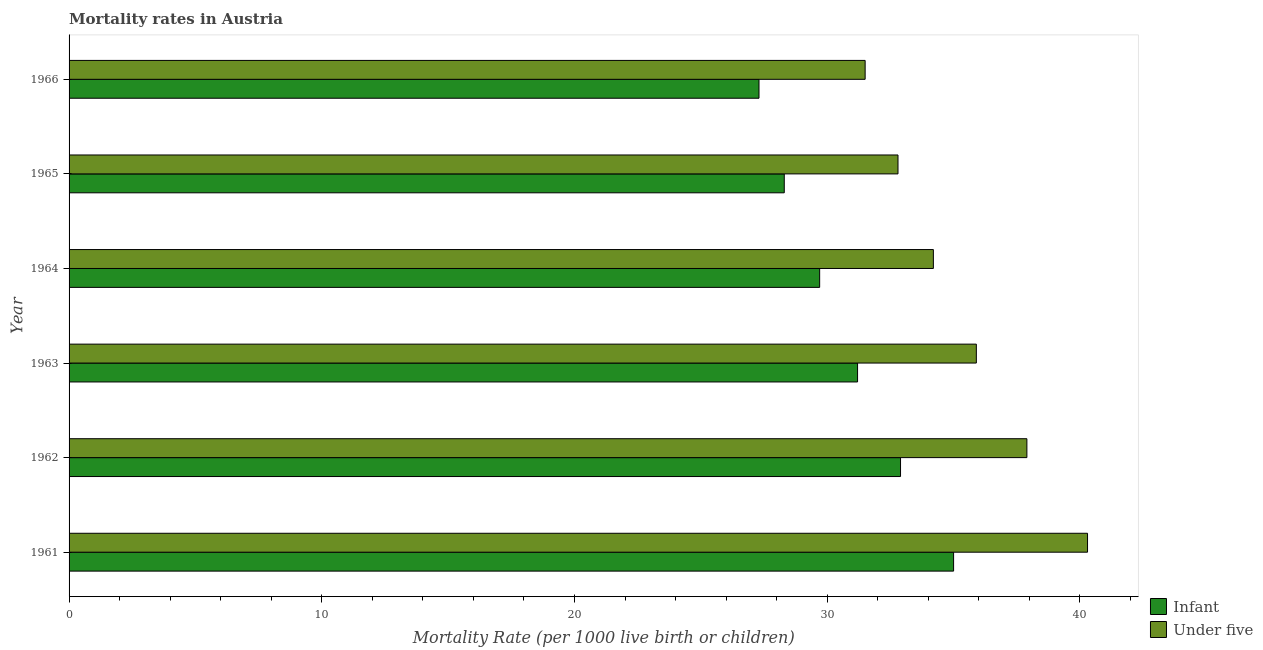How many different coloured bars are there?
Give a very brief answer. 2. What is the label of the 1st group of bars from the top?
Keep it short and to the point. 1966. In how many cases, is the number of bars for a given year not equal to the number of legend labels?
Provide a short and direct response. 0. What is the infant mortality rate in 1965?
Offer a terse response. 28.3. Across all years, what is the maximum under-5 mortality rate?
Your answer should be compact. 40.3. Across all years, what is the minimum under-5 mortality rate?
Your answer should be compact. 31.5. In which year was the under-5 mortality rate maximum?
Your response must be concise. 1961. In which year was the infant mortality rate minimum?
Your response must be concise. 1966. What is the total under-5 mortality rate in the graph?
Provide a succinct answer. 212.6. What is the difference between the under-5 mortality rate in 1963 and that in 1966?
Offer a terse response. 4.4. What is the difference between the infant mortality rate in 1962 and the under-5 mortality rate in 1966?
Offer a very short reply. 1.4. What is the average infant mortality rate per year?
Make the answer very short. 30.73. What is the ratio of the under-5 mortality rate in 1964 to that in 1965?
Your response must be concise. 1.04. Is the difference between the infant mortality rate in 1961 and 1963 greater than the difference between the under-5 mortality rate in 1961 and 1963?
Your answer should be very brief. No. What does the 2nd bar from the top in 1964 represents?
Keep it short and to the point. Infant. What does the 2nd bar from the bottom in 1962 represents?
Provide a short and direct response. Under five. How many bars are there?
Keep it short and to the point. 12. Are all the bars in the graph horizontal?
Ensure brevity in your answer.  Yes. How many years are there in the graph?
Keep it short and to the point. 6. What is the difference between two consecutive major ticks on the X-axis?
Provide a succinct answer. 10. Does the graph contain grids?
Provide a succinct answer. No. How are the legend labels stacked?
Provide a succinct answer. Vertical. What is the title of the graph?
Your answer should be compact. Mortality rates in Austria. What is the label or title of the X-axis?
Keep it short and to the point. Mortality Rate (per 1000 live birth or children). What is the label or title of the Y-axis?
Keep it short and to the point. Year. What is the Mortality Rate (per 1000 live birth or children) in Under five in 1961?
Give a very brief answer. 40.3. What is the Mortality Rate (per 1000 live birth or children) of Infant in 1962?
Keep it short and to the point. 32.9. What is the Mortality Rate (per 1000 live birth or children) of Under five in 1962?
Your answer should be compact. 37.9. What is the Mortality Rate (per 1000 live birth or children) of Infant in 1963?
Ensure brevity in your answer.  31.2. What is the Mortality Rate (per 1000 live birth or children) of Under five in 1963?
Provide a succinct answer. 35.9. What is the Mortality Rate (per 1000 live birth or children) of Infant in 1964?
Ensure brevity in your answer.  29.7. What is the Mortality Rate (per 1000 live birth or children) of Under five in 1964?
Ensure brevity in your answer.  34.2. What is the Mortality Rate (per 1000 live birth or children) of Infant in 1965?
Offer a terse response. 28.3. What is the Mortality Rate (per 1000 live birth or children) in Under five in 1965?
Keep it short and to the point. 32.8. What is the Mortality Rate (per 1000 live birth or children) of Infant in 1966?
Provide a succinct answer. 27.3. What is the Mortality Rate (per 1000 live birth or children) in Under five in 1966?
Provide a succinct answer. 31.5. Across all years, what is the maximum Mortality Rate (per 1000 live birth or children) in Infant?
Provide a succinct answer. 35. Across all years, what is the maximum Mortality Rate (per 1000 live birth or children) of Under five?
Your answer should be compact. 40.3. Across all years, what is the minimum Mortality Rate (per 1000 live birth or children) in Infant?
Your answer should be compact. 27.3. Across all years, what is the minimum Mortality Rate (per 1000 live birth or children) in Under five?
Offer a very short reply. 31.5. What is the total Mortality Rate (per 1000 live birth or children) in Infant in the graph?
Your answer should be compact. 184.4. What is the total Mortality Rate (per 1000 live birth or children) in Under five in the graph?
Your response must be concise. 212.6. What is the difference between the Mortality Rate (per 1000 live birth or children) of Infant in 1961 and that in 1962?
Your answer should be compact. 2.1. What is the difference between the Mortality Rate (per 1000 live birth or children) of Infant in 1961 and that in 1963?
Keep it short and to the point. 3.8. What is the difference between the Mortality Rate (per 1000 live birth or children) of Under five in 1961 and that in 1963?
Offer a very short reply. 4.4. What is the difference between the Mortality Rate (per 1000 live birth or children) in Infant in 1961 and that in 1964?
Provide a succinct answer. 5.3. What is the difference between the Mortality Rate (per 1000 live birth or children) in Under five in 1961 and that in 1964?
Your response must be concise. 6.1. What is the difference between the Mortality Rate (per 1000 live birth or children) of Infant in 1961 and that in 1965?
Make the answer very short. 6.7. What is the difference between the Mortality Rate (per 1000 live birth or children) of Under five in 1961 and that in 1965?
Your answer should be compact. 7.5. What is the difference between the Mortality Rate (per 1000 live birth or children) of Under five in 1961 and that in 1966?
Make the answer very short. 8.8. What is the difference between the Mortality Rate (per 1000 live birth or children) of Infant in 1962 and that in 1963?
Ensure brevity in your answer.  1.7. What is the difference between the Mortality Rate (per 1000 live birth or children) in Under five in 1962 and that in 1964?
Make the answer very short. 3.7. What is the difference between the Mortality Rate (per 1000 live birth or children) of Under five in 1962 and that in 1965?
Offer a very short reply. 5.1. What is the difference between the Mortality Rate (per 1000 live birth or children) in Infant in 1962 and that in 1966?
Provide a short and direct response. 5.6. What is the difference between the Mortality Rate (per 1000 live birth or children) in Under five in 1962 and that in 1966?
Offer a very short reply. 6.4. What is the difference between the Mortality Rate (per 1000 live birth or children) in Infant in 1963 and that in 1964?
Offer a very short reply. 1.5. What is the difference between the Mortality Rate (per 1000 live birth or children) of Under five in 1963 and that in 1964?
Keep it short and to the point. 1.7. What is the difference between the Mortality Rate (per 1000 live birth or children) in Infant in 1963 and that in 1965?
Provide a short and direct response. 2.9. What is the difference between the Mortality Rate (per 1000 live birth or children) of Under five in 1963 and that in 1965?
Your answer should be very brief. 3.1. What is the difference between the Mortality Rate (per 1000 live birth or children) of Under five in 1963 and that in 1966?
Keep it short and to the point. 4.4. What is the difference between the Mortality Rate (per 1000 live birth or children) in Under five in 1964 and that in 1965?
Offer a very short reply. 1.4. What is the difference between the Mortality Rate (per 1000 live birth or children) of Infant in 1965 and that in 1966?
Make the answer very short. 1. What is the difference between the Mortality Rate (per 1000 live birth or children) of Under five in 1965 and that in 1966?
Offer a terse response. 1.3. What is the difference between the Mortality Rate (per 1000 live birth or children) of Infant in 1961 and the Mortality Rate (per 1000 live birth or children) of Under five in 1965?
Make the answer very short. 2.2. What is the difference between the Mortality Rate (per 1000 live birth or children) of Infant in 1961 and the Mortality Rate (per 1000 live birth or children) of Under five in 1966?
Offer a terse response. 3.5. What is the difference between the Mortality Rate (per 1000 live birth or children) in Infant in 1962 and the Mortality Rate (per 1000 live birth or children) in Under five in 1965?
Keep it short and to the point. 0.1. What is the difference between the Mortality Rate (per 1000 live birth or children) in Infant in 1962 and the Mortality Rate (per 1000 live birth or children) in Under five in 1966?
Provide a short and direct response. 1.4. What is the difference between the Mortality Rate (per 1000 live birth or children) of Infant in 1963 and the Mortality Rate (per 1000 live birth or children) of Under five in 1964?
Keep it short and to the point. -3. What is the difference between the Mortality Rate (per 1000 live birth or children) in Infant in 1963 and the Mortality Rate (per 1000 live birth or children) in Under five in 1965?
Offer a terse response. -1.6. What is the difference between the Mortality Rate (per 1000 live birth or children) in Infant in 1963 and the Mortality Rate (per 1000 live birth or children) in Under five in 1966?
Your answer should be compact. -0.3. What is the difference between the Mortality Rate (per 1000 live birth or children) of Infant in 1964 and the Mortality Rate (per 1000 live birth or children) of Under five in 1965?
Offer a terse response. -3.1. What is the average Mortality Rate (per 1000 live birth or children) in Infant per year?
Offer a terse response. 30.73. What is the average Mortality Rate (per 1000 live birth or children) of Under five per year?
Your response must be concise. 35.43. What is the ratio of the Mortality Rate (per 1000 live birth or children) in Infant in 1961 to that in 1962?
Offer a very short reply. 1.06. What is the ratio of the Mortality Rate (per 1000 live birth or children) of Under five in 1961 to that in 1962?
Offer a terse response. 1.06. What is the ratio of the Mortality Rate (per 1000 live birth or children) in Infant in 1961 to that in 1963?
Your answer should be very brief. 1.12. What is the ratio of the Mortality Rate (per 1000 live birth or children) of Under five in 1961 to that in 1963?
Provide a short and direct response. 1.12. What is the ratio of the Mortality Rate (per 1000 live birth or children) in Infant in 1961 to that in 1964?
Provide a succinct answer. 1.18. What is the ratio of the Mortality Rate (per 1000 live birth or children) in Under five in 1961 to that in 1964?
Give a very brief answer. 1.18. What is the ratio of the Mortality Rate (per 1000 live birth or children) in Infant in 1961 to that in 1965?
Give a very brief answer. 1.24. What is the ratio of the Mortality Rate (per 1000 live birth or children) in Under five in 1961 to that in 1965?
Offer a terse response. 1.23. What is the ratio of the Mortality Rate (per 1000 live birth or children) of Infant in 1961 to that in 1966?
Your response must be concise. 1.28. What is the ratio of the Mortality Rate (per 1000 live birth or children) in Under five in 1961 to that in 1966?
Ensure brevity in your answer.  1.28. What is the ratio of the Mortality Rate (per 1000 live birth or children) in Infant in 1962 to that in 1963?
Provide a short and direct response. 1.05. What is the ratio of the Mortality Rate (per 1000 live birth or children) in Under five in 1962 to that in 1963?
Keep it short and to the point. 1.06. What is the ratio of the Mortality Rate (per 1000 live birth or children) in Infant in 1962 to that in 1964?
Ensure brevity in your answer.  1.11. What is the ratio of the Mortality Rate (per 1000 live birth or children) of Under five in 1962 to that in 1964?
Your answer should be very brief. 1.11. What is the ratio of the Mortality Rate (per 1000 live birth or children) of Infant in 1962 to that in 1965?
Provide a short and direct response. 1.16. What is the ratio of the Mortality Rate (per 1000 live birth or children) of Under five in 1962 to that in 1965?
Your response must be concise. 1.16. What is the ratio of the Mortality Rate (per 1000 live birth or children) in Infant in 1962 to that in 1966?
Make the answer very short. 1.21. What is the ratio of the Mortality Rate (per 1000 live birth or children) in Under five in 1962 to that in 1966?
Give a very brief answer. 1.2. What is the ratio of the Mortality Rate (per 1000 live birth or children) in Infant in 1963 to that in 1964?
Your answer should be compact. 1.05. What is the ratio of the Mortality Rate (per 1000 live birth or children) of Under five in 1963 to that in 1964?
Your answer should be compact. 1.05. What is the ratio of the Mortality Rate (per 1000 live birth or children) of Infant in 1963 to that in 1965?
Your answer should be very brief. 1.1. What is the ratio of the Mortality Rate (per 1000 live birth or children) in Under five in 1963 to that in 1965?
Keep it short and to the point. 1.09. What is the ratio of the Mortality Rate (per 1000 live birth or children) in Under five in 1963 to that in 1966?
Give a very brief answer. 1.14. What is the ratio of the Mortality Rate (per 1000 live birth or children) in Infant in 1964 to that in 1965?
Offer a terse response. 1.05. What is the ratio of the Mortality Rate (per 1000 live birth or children) in Under five in 1964 to that in 1965?
Offer a terse response. 1.04. What is the ratio of the Mortality Rate (per 1000 live birth or children) in Infant in 1964 to that in 1966?
Your response must be concise. 1.09. What is the ratio of the Mortality Rate (per 1000 live birth or children) in Under five in 1964 to that in 1966?
Offer a very short reply. 1.09. What is the ratio of the Mortality Rate (per 1000 live birth or children) of Infant in 1965 to that in 1966?
Provide a short and direct response. 1.04. What is the ratio of the Mortality Rate (per 1000 live birth or children) in Under five in 1965 to that in 1966?
Offer a very short reply. 1.04. What is the difference between the highest and the lowest Mortality Rate (per 1000 live birth or children) in Infant?
Your answer should be compact. 7.7. What is the difference between the highest and the lowest Mortality Rate (per 1000 live birth or children) of Under five?
Ensure brevity in your answer.  8.8. 